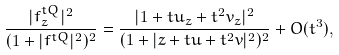<formula> <loc_0><loc_0><loc_500><loc_500>\frac { | f _ { z } ^ { t Q } | ^ { 2 } } { ( 1 + | f ^ { t Q } | ^ { 2 } ) ^ { 2 } } & = \frac { | 1 + t u _ { z } + t ^ { 2 } v _ { z } | ^ { 2 } } { ( 1 + | z + t u + t ^ { 2 } v | ^ { 2 } ) ^ { 2 } } + O ( t ^ { 3 } ) , \\</formula> 